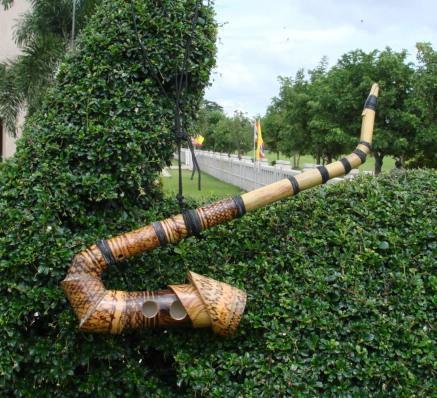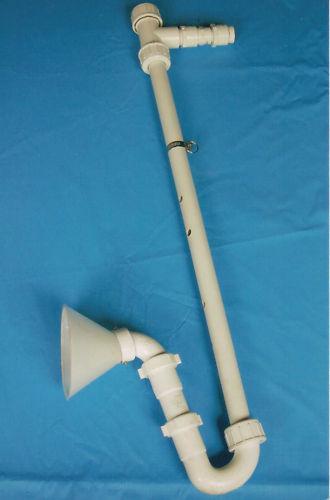The first image is the image on the left, the second image is the image on the right. For the images shown, is this caption "Someone is playing an instrument." true? Answer yes or no. No. The first image is the image on the left, the second image is the image on the right. Analyze the images presented: Is the assertion "Two people can be seen holding a musical instrument." valid? Answer yes or no. No. 